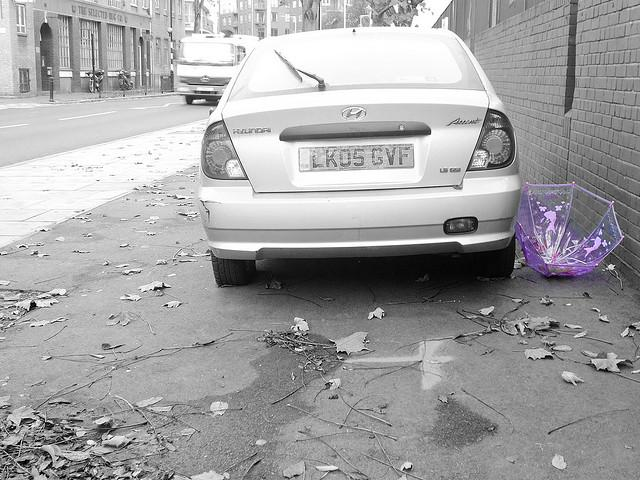What is this model of car called in South Korea? Please explain your reasoning. hyundai verna. The car is an accent which is a verna in south korea. 